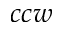Convert formula to latex. <formula><loc_0><loc_0><loc_500><loc_500>c c w</formula> 